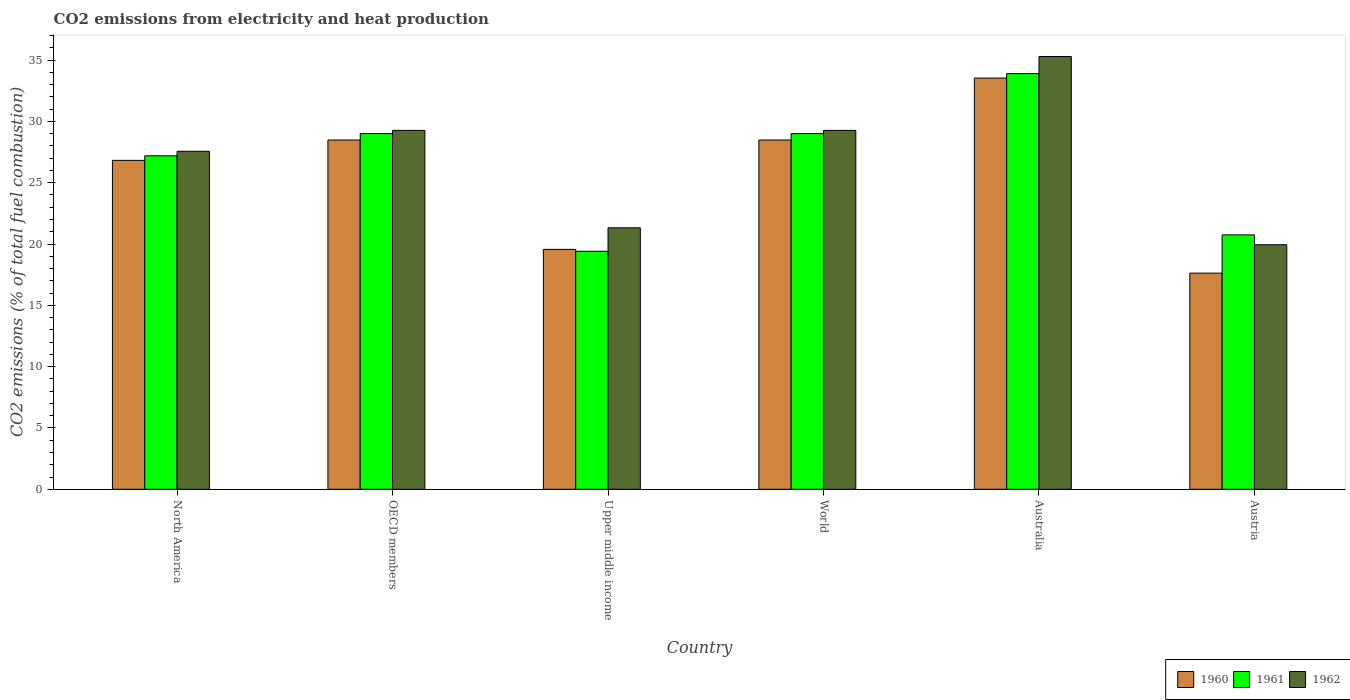How many different coloured bars are there?
Your answer should be compact. 3. What is the label of the 3rd group of bars from the left?
Provide a succinct answer. Upper middle income. What is the amount of CO2 emitted in 1962 in Austria?
Offer a very short reply. 19.94. Across all countries, what is the maximum amount of CO2 emitted in 1962?
Make the answer very short. 35.29. Across all countries, what is the minimum amount of CO2 emitted in 1961?
Your answer should be very brief. 19.41. What is the total amount of CO2 emitted in 1960 in the graph?
Your answer should be compact. 154.5. What is the difference between the amount of CO2 emitted in 1960 in Australia and that in Upper middle income?
Offer a very short reply. 13.97. What is the difference between the amount of CO2 emitted in 1962 in Upper middle income and the amount of CO2 emitted in 1960 in World?
Make the answer very short. -7.16. What is the average amount of CO2 emitted in 1961 per country?
Your answer should be very brief. 26.54. What is the difference between the amount of CO2 emitted of/in 1960 and amount of CO2 emitted of/in 1961 in Austria?
Keep it short and to the point. -3.12. What is the ratio of the amount of CO2 emitted in 1960 in North America to that in World?
Your answer should be compact. 0.94. Is the amount of CO2 emitted in 1962 in Austria less than that in North America?
Your response must be concise. Yes. What is the difference between the highest and the second highest amount of CO2 emitted in 1962?
Ensure brevity in your answer.  6.02. What is the difference between the highest and the lowest amount of CO2 emitted in 1962?
Your answer should be very brief. 15.35. In how many countries, is the amount of CO2 emitted in 1960 greater than the average amount of CO2 emitted in 1960 taken over all countries?
Your response must be concise. 4. What does the 1st bar from the left in World represents?
Offer a very short reply. 1960. What does the 3rd bar from the right in OECD members represents?
Provide a short and direct response. 1960. Are all the bars in the graph horizontal?
Provide a short and direct response. No. Are the values on the major ticks of Y-axis written in scientific E-notation?
Ensure brevity in your answer.  No. Does the graph contain grids?
Your response must be concise. No. How are the legend labels stacked?
Your answer should be compact. Horizontal. What is the title of the graph?
Provide a succinct answer. CO2 emissions from electricity and heat production. Does "1994" appear as one of the legend labels in the graph?
Your response must be concise. No. What is the label or title of the Y-axis?
Your response must be concise. CO2 emissions (% of total fuel combustion). What is the CO2 emissions (% of total fuel combustion) of 1960 in North America?
Provide a succinct answer. 26.82. What is the CO2 emissions (% of total fuel combustion) of 1961 in North America?
Ensure brevity in your answer.  27.19. What is the CO2 emissions (% of total fuel combustion) in 1962 in North America?
Give a very brief answer. 27.56. What is the CO2 emissions (% of total fuel combustion) in 1960 in OECD members?
Ensure brevity in your answer.  28.48. What is the CO2 emissions (% of total fuel combustion) in 1961 in OECD members?
Make the answer very short. 29. What is the CO2 emissions (% of total fuel combustion) in 1962 in OECD members?
Your response must be concise. 29.26. What is the CO2 emissions (% of total fuel combustion) of 1960 in Upper middle income?
Your answer should be very brief. 19.56. What is the CO2 emissions (% of total fuel combustion) of 1961 in Upper middle income?
Keep it short and to the point. 19.41. What is the CO2 emissions (% of total fuel combustion) in 1962 in Upper middle income?
Provide a succinct answer. 21.32. What is the CO2 emissions (% of total fuel combustion) in 1960 in World?
Make the answer very short. 28.48. What is the CO2 emissions (% of total fuel combustion) in 1961 in World?
Your answer should be very brief. 29. What is the CO2 emissions (% of total fuel combustion) in 1962 in World?
Your answer should be compact. 29.26. What is the CO2 emissions (% of total fuel combustion) of 1960 in Australia?
Ensure brevity in your answer.  33.53. What is the CO2 emissions (% of total fuel combustion) of 1961 in Australia?
Provide a short and direct response. 33.89. What is the CO2 emissions (% of total fuel combustion) in 1962 in Australia?
Your answer should be compact. 35.29. What is the CO2 emissions (% of total fuel combustion) in 1960 in Austria?
Keep it short and to the point. 17.63. What is the CO2 emissions (% of total fuel combustion) in 1961 in Austria?
Make the answer very short. 20.75. What is the CO2 emissions (% of total fuel combustion) of 1962 in Austria?
Offer a very short reply. 19.94. Across all countries, what is the maximum CO2 emissions (% of total fuel combustion) in 1960?
Give a very brief answer. 33.53. Across all countries, what is the maximum CO2 emissions (% of total fuel combustion) in 1961?
Provide a short and direct response. 33.89. Across all countries, what is the maximum CO2 emissions (% of total fuel combustion) of 1962?
Offer a terse response. 35.29. Across all countries, what is the minimum CO2 emissions (% of total fuel combustion) of 1960?
Your answer should be very brief. 17.63. Across all countries, what is the minimum CO2 emissions (% of total fuel combustion) in 1961?
Offer a very short reply. 19.41. Across all countries, what is the minimum CO2 emissions (% of total fuel combustion) in 1962?
Make the answer very short. 19.94. What is the total CO2 emissions (% of total fuel combustion) of 1960 in the graph?
Ensure brevity in your answer.  154.5. What is the total CO2 emissions (% of total fuel combustion) in 1961 in the graph?
Ensure brevity in your answer.  159.25. What is the total CO2 emissions (% of total fuel combustion) of 1962 in the graph?
Ensure brevity in your answer.  162.64. What is the difference between the CO2 emissions (% of total fuel combustion) in 1960 in North America and that in OECD members?
Ensure brevity in your answer.  -1.66. What is the difference between the CO2 emissions (% of total fuel combustion) of 1961 in North America and that in OECD members?
Keep it short and to the point. -1.81. What is the difference between the CO2 emissions (% of total fuel combustion) in 1962 in North America and that in OECD members?
Your answer should be compact. -1.7. What is the difference between the CO2 emissions (% of total fuel combustion) in 1960 in North America and that in Upper middle income?
Offer a terse response. 7.26. What is the difference between the CO2 emissions (% of total fuel combustion) of 1961 in North America and that in Upper middle income?
Your response must be concise. 7.78. What is the difference between the CO2 emissions (% of total fuel combustion) in 1962 in North America and that in Upper middle income?
Ensure brevity in your answer.  6.24. What is the difference between the CO2 emissions (% of total fuel combustion) in 1960 in North America and that in World?
Make the answer very short. -1.66. What is the difference between the CO2 emissions (% of total fuel combustion) in 1961 in North America and that in World?
Provide a short and direct response. -1.81. What is the difference between the CO2 emissions (% of total fuel combustion) of 1962 in North America and that in World?
Make the answer very short. -1.7. What is the difference between the CO2 emissions (% of total fuel combustion) in 1960 in North America and that in Australia?
Give a very brief answer. -6.71. What is the difference between the CO2 emissions (% of total fuel combustion) in 1961 in North America and that in Australia?
Provide a succinct answer. -6.7. What is the difference between the CO2 emissions (% of total fuel combustion) of 1962 in North America and that in Australia?
Give a very brief answer. -7.73. What is the difference between the CO2 emissions (% of total fuel combustion) in 1960 in North America and that in Austria?
Provide a succinct answer. 9.2. What is the difference between the CO2 emissions (% of total fuel combustion) of 1961 in North America and that in Austria?
Give a very brief answer. 6.45. What is the difference between the CO2 emissions (% of total fuel combustion) in 1962 in North America and that in Austria?
Offer a terse response. 7.62. What is the difference between the CO2 emissions (% of total fuel combustion) of 1960 in OECD members and that in Upper middle income?
Your answer should be compact. 8.92. What is the difference between the CO2 emissions (% of total fuel combustion) in 1961 in OECD members and that in Upper middle income?
Offer a terse response. 9.6. What is the difference between the CO2 emissions (% of total fuel combustion) in 1962 in OECD members and that in Upper middle income?
Provide a short and direct response. 7.95. What is the difference between the CO2 emissions (% of total fuel combustion) of 1961 in OECD members and that in World?
Provide a short and direct response. 0. What is the difference between the CO2 emissions (% of total fuel combustion) of 1962 in OECD members and that in World?
Your response must be concise. 0. What is the difference between the CO2 emissions (% of total fuel combustion) in 1960 in OECD members and that in Australia?
Make the answer very short. -5.05. What is the difference between the CO2 emissions (% of total fuel combustion) in 1961 in OECD members and that in Australia?
Keep it short and to the point. -4.89. What is the difference between the CO2 emissions (% of total fuel combustion) of 1962 in OECD members and that in Australia?
Offer a terse response. -6.02. What is the difference between the CO2 emissions (% of total fuel combustion) of 1960 in OECD members and that in Austria?
Make the answer very short. 10.85. What is the difference between the CO2 emissions (% of total fuel combustion) of 1961 in OECD members and that in Austria?
Offer a terse response. 8.26. What is the difference between the CO2 emissions (% of total fuel combustion) in 1962 in OECD members and that in Austria?
Your response must be concise. 9.33. What is the difference between the CO2 emissions (% of total fuel combustion) of 1960 in Upper middle income and that in World?
Offer a terse response. -8.92. What is the difference between the CO2 emissions (% of total fuel combustion) of 1961 in Upper middle income and that in World?
Your answer should be compact. -9.6. What is the difference between the CO2 emissions (% of total fuel combustion) in 1962 in Upper middle income and that in World?
Your answer should be very brief. -7.95. What is the difference between the CO2 emissions (% of total fuel combustion) in 1960 in Upper middle income and that in Australia?
Make the answer very short. -13.97. What is the difference between the CO2 emissions (% of total fuel combustion) of 1961 in Upper middle income and that in Australia?
Offer a terse response. -14.49. What is the difference between the CO2 emissions (% of total fuel combustion) in 1962 in Upper middle income and that in Australia?
Your answer should be very brief. -13.97. What is the difference between the CO2 emissions (% of total fuel combustion) of 1960 in Upper middle income and that in Austria?
Offer a terse response. 1.94. What is the difference between the CO2 emissions (% of total fuel combustion) in 1961 in Upper middle income and that in Austria?
Provide a succinct answer. -1.34. What is the difference between the CO2 emissions (% of total fuel combustion) in 1962 in Upper middle income and that in Austria?
Offer a very short reply. 1.38. What is the difference between the CO2 emissions (% of total fuel combustion) of 1960 in World and that in Australia?
Offer a terse response. -5.05. What is the difference between the CO2 emissions (% of total fuel combustion) of 1961 in World and that in Australia?
Give a very brief answer. -4.89. What is the difference between the CO2 emissions (% of total fuel combustion) in 1962 in World and that in Australia?
Ensure brevity in your answer.  -6.02. What is the difference between the CO2 emissions (% of total fuel combustion) in 1960 in World and that in Austria?
Make the answer very short. 10.85. What is the difference between the CO2 emissions (% of total fuel combustion) in 1961 in World and that in Austria?
Give a very brief answer. 8.26. What is the difference between the CO2 emissions (% of total fuel combustion) in 1962 in World and that in Austria?
Offer a terse response. 9.33. What is the difference between the CO2 emissions (% of total fuel combustion) of 1960 in Australia and that in Austria?
Keep it short and to the point. 15.91. What is the difference between the CO2 emissions (% of total fuel combustion) in 1961 in Australia and that in Austria?
Provide a short and direct response. 13.15. What is the difference between the CO2 emissions (% of total fuel combustion) of 1962 in Australia and that in Austria?
Ensure brevity in your answer.  15.35. What is the difference between the CO2 emissions (% of total fuel combustion) of 1960 in North America and the CO2 emissions (% of total fuel combustion) of 1961 in OECD members?
Provide a succinct answer. -2.18. What is the difference between the CO2 emissions (% of total fuel combustion) of 1960 in North America and the CO2 emissions (% of total fuel combustion) of 1962 in OECD members?
Offer a very short reply. -2.44. What is the difference between the CO2 emissions (% of total fuel combustion) in 1961 in North America and the CO2 emissions (% of total fuel combustion) in 1962 in OECD members?
Your answer should be compact. -2.07. What is the difference between the CO2 emissions (% of total fuel combustion) of 1960 in North America and the CO2 emissions (% of total fuel combustion) of 1961 in Upper middle income?
Provide a succinct answer. 7.41. What is the difference between the CO2 emissions (% of total fuel combustion) in 1960 in North America and the CO2 emissions (% of total fuel combustion) in 1962 in Upper middle income?
Ensure brevity in your answer.  5.5. What is the difference between the CO2 emissions (% of total fuel combustion) in 1961 in North America and the CO2 emissions (% of total fuel combustion) in 1962 in Upper middle income?
Keep it short and to the point. 5.87. What is the difference between the CO2 emissions (% of total fuel combustion) of 1960 in North America and the CO2 emissions (% of total fuel combustion) of 1961 in World?
Your answer should be very brief. -2.18. What is the difference between the CO2 emissions (% of total fuel combustion) of 1960 in North America and the CO2 emissions (% of total fuel combustion) of 1962 in World?
Provide a succinct answer. -2.44. What is the difference between the CO2 emissions (% of total fuel combustion) of 1961 in North America and the CO2 emissions (% of total fuel combustion) of 1962 in World?
Give a very brief answer. -2.07. What is the difference between the CO2 emissions (% of total fuel combustion) of 1960 in North America and the CO2 emissions (% of total fuel combustion) of 1961 in Australia?
Your answer should be very brief. -7.07. What is the difference between the CO2 emissions (% of total fuel combustion) in 1960 in North America and the CO2 emissions (% of total fuel combustion) in 1962 in Australia?
Make the answer very short. -8.47. What is the difference between the CO2 emissions (% of total fuel combustion) of 1961 in North America and the CO2 emissions (% of total fuel combustion) of 1962 in Australia?
Make the answer very short. -8.1. What is the difference between the CO2 emissions (% of total fuel combustion) of 1960 in North America and the CO2 emissions (% of total fuel combustion) of 1961 in Austria?
Offer a very short reply. 6.08. What is the difference between the CO2 emissions (% of total fuel combustion) in 1960 in North America and the CO2 emissions (% of total fuel combustion) in 1962 in Austria?
Your answer should be compact. 6.88. What is the difference between the CO2 emissions (% of total fuel combustion) of 1961 in North America and the CO2 emissions (% of total fuel combustion) of 1962 in Austria?
Offer a very short reply. 7.25. What is the difference between the CO2 emissions (% of total fuel combustion) in 1960 in OECD members and the CO2 emissions (% of total fuel combustion) in 1961 in Upper middle income?
Keep it short and to the point. 9.07. What is the difference between the CO2 emissions (% of total fuel combustion) of 1960 in OECD members and the CO2 emissions (% of total fuel combustion) of 1962 in Upper middle income?
Keep it short and to the point. 7.16. What is the difference between the CO2 emissions (% of total fuel combustion) of 1961 in OECD members and the CO2 emissions (% of total fuel combustion) of 1962 in Upper middle income?
Provide a succinct answer. 7.68. What is the difference between the CO2 emissions (% of total fuel combustion) in 1960 in OECD members and the CO2 emissions (% of total fuel combustion) in 1961 in World?
Ensure brevity in your answer.  -0.52. What is the difference between the CO2 emissions (% of total fuel combustion) of 1960 in OECD members and the CO2 emissions (% of total fuel combustion) of 1962 in World?
Keep it short and to the point. -0.79. What is the difference between the CO2 emissions (% of total fuel combustion) in 1961 in OECD members and the CO2 emissions (% of total fuel combustion) in 1962 in World?
Your answer should be compact. -0.26. What is the difference between the CO2 emissions (% of total fuel combustion) of 1960 in OECD members and the CO2 emissions (% of total fuel combustion) of 1961 in Australia?
Your answer should be compact. -5.41. What is the difference between the CO2 emissions (% of total fuel combustion) in 1960 in OECD members and the CO2 emissions (% of total fuel combustion) in 1962 in Australia?
Offer a terse response. -6.81. What is the difference between the CO2 emissions (% of total fuel combustion) in 1961 in OECD members and the CO2 emissions (% of total fuel combustion) in 1962 in Australia?
Your answer should be very brief. -6.29. What is the difference between the CO2 emissions (% of total fuel combustion) of 1960 in OECD members and the CO2 emissions (% of total fuel combustion) of 1961 in Austria?
Provide a short and direct response. 7.73. What is the difference between the CO2 emissions (% of total fuel combustion) in 1960 in OECD members and the CO2 emissions (% of total fuel combustion) in 1962 in Austria?
Your answer should be very brief. 8.54. What is the difference between the CO2 emissions (% of total fuel combustion) of 1961 in OECD members and the CO2 emissions (% of total fuel combustion) of 1962 in Austria?
Your answer should be very brief. 9.06. What is the difference between the CO2 emissions (% of total fuel combustion) in 1960 in Upper middle income and the CO2 emissions (% of total fuel combustion) in 1961 in World?
Offer a very short reply. -9.44. What is the difference between the CO2 emissions (% of total fuel combustion) in 1960 in Upper middle income and the CO2 emissions (% of total fuel combustion) in 1962 in World?
Your answer should be compact. -9.7. What is the difference between the CO2 emissions (% of total fuel combustion) of 1961 in Upper middle income and the CO2 emissions (% of total fuel combustion) of 1962 in World?
Keep it short and to the point. -9.86. What is the difference between the CO2 emissions (% of total fuel combustion) in 1960 in Upper middle income and the CO2 emissions (% of total fuel combustion) in 1961 in Australia?
Provide a succinct answer. -14.33. What is the difference between the CO2 emissions (% of total fuel combustion) of 1960 in Upper middle income and the CO2 emissions (% of total fuel combustion) of 1962 in Australia?
Make the answer very short. -15.73. What is the difference between the CO2 emissions (% of total fuel combustion) of 1961 in Upper middle income and the CO2 emissions (% of total fuel combustion) of 1962 in Australia?
Your answer should be compact. -15.88. What is the difference between the CO2 emissions (% of total fuel combustion) of 1960 in Upper middle income and the CO2 emissions (% of total fuel combustion) of 1961 in Austria?
Make the answer very short. -1.18. What is the difference between the CO2 emissions (% of total fuel combustion) in 1960 in Upper middle income and the CO2 emissions (% of total fuel combustion) in 1962 in Austria?
Make the answer very short. -0.38. What is the difference between the CO2 emissions (% of total fuel combustion) in 1961 in Upper middle income and the CO2 emissions (% of total fuel combustion) in 1962 in Austria?
Ensure brevity in your answer.  -0.53. What is the difference between the CO2 emissions (% of total fuel combustion) in 1960 in World and the CO2 emissions (% of total fuel combustion) in 1961 in Australia?
Ensure brevity in your answer.  -5.41. What is the difference between the CO2 emissions (% of total fuel combustion) of 1960 in World and the CO2 emissions (% of total fuel combustion) of 1962 in Australia?
Your answer should be compact. -6.81. What is the difference between the CO2 emissions (% of total fuel combustion) of 1961 in World and the CO2 emissions (% of total fuel combustion) of 1962 in Australia?
Keep it short and to the point. -6.29. What is the difference between the CO2 emissions (% of total fuel combustion) of 1960 in World and the CO2 emissions (% of total fuel combustion) of 1961 in Austria?
Your response must be concise. 7.73. What is the difference between the CO2 emissions (% of total fuel combustion) of 1960 in World and the CO2 emissions (% of total fuel combustion) of 1962 in Austria?
Provide a succinct answer. 8.54. What is the difference between the CO2 emissions (% of total fuel combustion) of 1961 in World and the CO2 emissions (% of total fuel combustion) of 1962 in Austria?
Ensure brevity in your answer.  9.06. What is the difference between the CO2 emissions (% of total fuel combustion) in 1960 in Australia and the CO2 emissions (% of total fuel combustion) in 1961 in Austria?
Offer a terse response. 12.79. What is the difference between the CO2 emissions (% of total fuel combustion) of 1960 in Australia and the CO2 emissions (% of total fuel combustion) of 1962 in Austria?
Make the answer very short. 13.59. What is the difference between the CO2 emissions (% of total fuel combustion) in 1961 in Australia and the CO2 emissions (% of total fuel combustion) in 1962 in Austria?
Your answer should be very brief. 13.95. What is the average CO2 emissions (% of total fuel combustion) of 1960 per country?
Make the answer very short. 25.75. What is the average CO2 emissions (% of total fuel combustion) in 1961 per country?
Offer a very short reply. 26.54. What is the average CO2 emissions (% of total fuel combustion) of 1962 per country?
Give a very brief answer. 27.11. What is the difference between the CO2 emissions (% of total fuel combustion) in 1960 and CO2 emissions (% of total fuel combustion) in 1961 in North America?
Ensure brevity in your answer.  -0.37. What is the difference between the CO2 emissions (% of total fuel combustion) in 1960 and CO2 emissions (% of total fuel combustion) in 1962 in North America?
Offer a terse response. -0.74. What is the difference between the CO2 emissions (% of total fuel combustion) of 1961 and CO2 emissions (% of total fuel combustion) of 1962 in North America?
Your answer should be compact. -0.37. What is the difference between the CO2 emissions (% of total fuel combustion) in 1960 and CO2 emissions (% of total fuel combustion) in 1961 in OECD members?
Your response must be concise. -0.52. What is the difference between the CO2 emissions (% of total fuel combustion) of 1960 and CO2 emissions (% of total fuel combustion) of 1962 in OECD members?
Ensure brevity in your answer.  -0.79. What is the difference between the CO2 emissions (% of total fuel combustion) of 1961 and CO2 emissions (% of total fuel combustion) of 1962 in OECD members?
Offer a terse response. -0.26. What is the difference between the CO2 emissions (% of total fuel combustion) in 1960 and CO2 emissions (% of total fuel combustion) in 1961 in Upper middle income?
Provide a succinct answer. 0.15. What is the difference between the CO2 emissions (% of total fuel combustion) in 1960 and CO2 emissions (% of total fuel combustion) in 1962 in Upper middle income?
Keep it short and to the point. -1.76. What is the difference between the CO2 emissions (% of total fuel combustion) of 1961 and CO2 emissions (% of total fuel combustion) of 1962 in Upper middle income?
Keep it short and to the point. -1.91. What is the difference between the CO2 emissions (% of total fuel combustion) in 1960 and CO2 emissions (% of total fuel combustion) in 1961 in World?
Offer a terse response. -0.52. What is the difference between the CO2 emissions (% of total fuel combustion) in 1960 and CO2 emissions (% of total fuel combustion) in 1962 in World?
Your answer should be compact. -0.79. What is the difference between the CO2 emissions (% of total fuel combustion) of 1961 and CO2 emissions (% of total fuel combustion) of 1962 in World?
Ensure brevity in your answer.  -0.26. What is the difference between the CO2 emissions (% of total fuel combustion) in 1960 and CO2 emissions (% of total fuel combustion) in 1961 in Australia?
Give a very brief answer. -0.36. What is the difference between the CO2 emissions (% of total fuel combustion) in 1960 and CO2 emissions (% of total fuel combustion) in 1962 in Australia?
Your answer should be compact. -1.76. What is the difference between the CO2 emissions (% of total fuel combustion) of 1961 and CO2 emissions (% of total fuel combustion) of 1962 in Australia?
Provide a short and direct response. -1.4. What is the difference between the CO2 emissions (% of total fuel combustion) of 1960 and CO2 emissions (% of total fuel combustion) of 1961 in Austria?
Give a very brief answer. -3.12. What is the difference between the CO2 emissions (% of total fuel combustion) of 1960 and CO2 emissions (% of total fuel combustion) of 1962 in Austria?
Your response must be concise. -2.31. What is the difference between the CO2 emissions (% of total fuel combustion) of 1961 and CO2 emissions (% of total fuel combustion) of 1962 in Austria?
Offer a very short reply. 0.81. What is the ratio of the CO2 emissions (% of total fuel combustion) in 1960 in North America to that in OECD members?
Ensure brevity in your answer.  0.94. What is the ratio of the CO2 emissions (% of total fuel combustion) in 1962 in North America to that in OECD members?
Offer a terse response. 0.94. What is the ratio of the CO2 emissions (% of total fuel combustion) of 1960 in North America to that in Upper middle income?
Give a very brief answer. 1.37. What is the ratio of the CO2 emissions (% of total fuel combustion) of 1961 in North America to that in Upper middle income?
Ensure brevity in your answer.  1.4. What is the ratio of the CO2 emissions (% of total fuel combustion) of 1962 in North America to that in Upper middle income?
Provide a short and direct response. 1.29. What is the ratio of the CO2 emissions (% of total fuel combustion) of 1960 in North America to that in World?
Your answer should be compact. 0.94. What is the ratio of the CO2 emissions (% of total fuel combustion) in 1962 in North America to that in World?
Your answer should be very brief. 0.94. What is the ratio of the CO2 emissions (% of total fuel combustion) of 1960 in North America to that in Australia?
Provide a succinct answer. 0.8. What is the ratio of the CO2 emissions (% of total fuel combustion) in 1961 in North America to that in Australia?
Keep it short and to the point. 0.8. What is the ratio of the CO2 emissions (% of total fuel combustion) in 1962 in North America to that in Australia?
Your response must be concise. 0.78. What is the ratio of the CO2 emissions (% of total fuel combustion) of 1960 in North America to that in Austria?
Your answer should be compact. 1.52. What is the ratio of the CO2 emissions (% of total fuel combustion) in 1961 in North America to that in Austria?
Your answer should be very brief. 1.31. What is the ratio of the CO2 emissions (% of total fuel combustion) of 1962 in North America to that in Austria?
Give a very brief answer. 1.38. What is the ratio of the CO2 emissions (% of total fuel combustion) in 1960 in OECD members to that in Upper middle income?
Provide a succinct answer. 1.46. What is the ratio of the CO2 emissions (% of total fuel combustion) in 1961 in OECD members to that in Upper middle income?
Your answer should be very brief. 1.49. What is the ratio of the CO2 emissions (% of total fuel combustion) of 1962 in OECD members to that in Upper middle income?
Give a very brief answer. 1.37. What is the ratio of the CO2 emissions (% of total fuel combustion) of 1961 in OECD members to that in World?
Your answer should be compact. 1. What is the ratio of the CO2 emissions (% of total fuel combustion) in 1960 in OECD members to that in Australia?
Your answer should be compact. 0.85. What is the ratio of the CO2 emissions (% of total fuel combustion) of 1961 in OECD members to that in Australia?
Provide a succinct answer. 0.86. What is the ratio of the CO2 emissions (% of total fuel combustion) in 1962 in OECD members to that in Australia?
Make the answer very short. 0.83. What is the ratio of the CO2 emissions (% of total fuel combustion) of 1960 in OECD members to that in Austria?
Give a very brief answer. 1.62. What is the ratio of the CO2 emissions (% of total fuel combustion) in 1961 in OECD members to that in Austria?
Provide a short and direct response. 1.4. What is the ratio of the CO2 emissions (% of total fuel combustion) in 1962 in OECD members to that in Austria?
Your response must be concise. 1.47. What is the ratio of the CO2 emissions (% of total fuel combustion) of 1960 in Upper middle income to that in World?
Ensure brevity in your answer.  0.69. What is the ratio of the CO2 emissions (% of total fuel combustion) of 1961 in Upper middle income to that in World?
Make the answer very short. 0.67. What is the ratio of the CO2 emissions (% of total fuel combustion) in 1962 in Upper middle income to that in World?
Your response must be concise. 0.73. What is the ratio of the CO2 emissions (% of total fuel combustion) of 1960 in Upper middle income to that in Australia?
Keep it short and to the point. 0.58. What is the ratio of the CO2 emissions (% of total fuel combustion) of 1961 in Upper middle income to that in Australia?
Give a very brief answer. 0.57. What is the ratio of the CO2 emissions (% of total fuel combustion) in 1962 in Upper middle income to that in Australia?
Offer a very short reply. 0.6. What is the ratio of the CO2 emissions (% of total fuel combustion) of 1960 in Upper middle income to that in Austria?
Ensure brevity in your answer.  1.11. What is the ratio of the CO2 emissions (% of total fuel combustion) of 1961 in Upper middle income to that in Austria?
Provide a short and direct response. 0.94. What is the ratio of the CO2 emissions (% of total fuel combustion) of 1962 in Upper middle income to that in Austria?
Your response must be concise. 1.07. What is the ratio of the CO2 emissions (% of total fuel combustion) of 1960 in World to that in Australia?
Ensure brevity in your answer.  0.85. What is the ratio of the CO2 emissions (% of total fuel combustion) in 1961 in World to that in Australia?
Offer a very short reply. 0.86. What is the ratio of the CO2 emissions (% of total fuel combustion) of 1962 in World to that in Australia?
Your response must be concise. 0.83. What is the ratio of the CO2 emissions (% of total fuel combustion) of 1960 in World to that in Austria?
Provide a short and direct response. 1.62. What is the ratio of the CO2 emissions (% of total fuel combustion) of 1961 in World to that in Austria?
Provide a succinct answer. 1.4. What is the ratio of the CO2 emissions (% of total fuel combustion) of 1962 in World to that in Austria?
Provide a short and direct response. 1.47. What is the ratio of the CO2 emissions (% of total fuel combustion) of 1960 in Australia to that in Austria?
Ensure brevity in your answer.  1.9. What is the ratio of the CO2 emissions (% of total fuel combustion) of 1961 in Australia to that in Austria?
Ensure brevity in your answer.  1.63. What is the ratio of the CO2 emissions (% of total fuel combustion) of 1962 in Australia to that in Austria?
Your answer should be compact. 1.77. What is the difference between the highest and the second highest CO2 emissions (% of total fuel combustion) in 1960?
Ensure brevity in your answer.  5.05. What is the difference between the highest and the second highest CO2 emissions (% of total fuel combustion) in 1961?
Provide a succinct answer. 4.89. What is the difference between the highest and the second highest CO2 emissions (% of total fuel combustion) of 1962?
Offer a very short reply. 6.02. What is the difference between the highest and the lowest CO2 emissions (% of total fuel combustion) in 1960?
Ensure brevity in your answer.  15.91. What is the difference between the highest and the lowest CO2 emissions (% of total fuel combustion) in 1961?
Make the answer very short. 14.49. What is the difference between the highest and the lowest CO2 emissions (% of total fuel combustion) in 1962?
Your response must be concise. 15.35. 